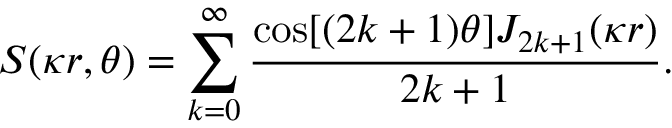<formula> <loc_0><loc_0><loc_500><loc_500>S ( \kappa r , \theta ) = \sum _ { k = 0 } ^ { \infty } \frac { \cos [ ( 2 k + 1 ) \theta ] J _ { 2 k + 1 } ( \kappa r ) } { 2 k + 1 } .</formula> 